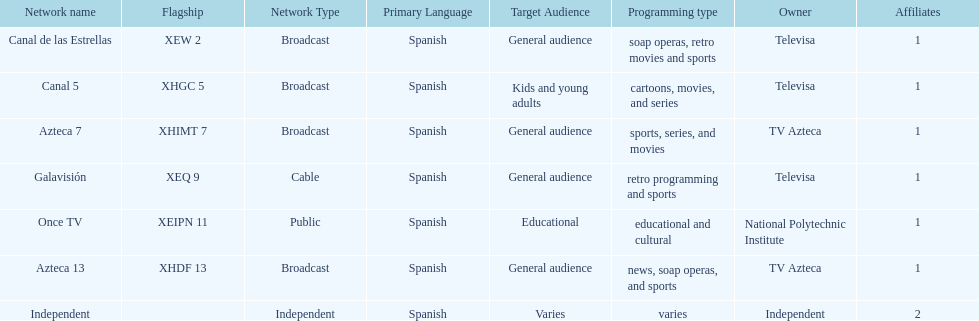What is the total number of affiliates among all the networks? 8. Write the full table. {'header': ['Network name', 'Flagship', 'Network Type', 'Primary Language', 'Target Audience', 'Programming type', 'Owner', 'Affiliates'], 'rows': [['Canal de las Estrellas', 'XEW 2', 'Broadcast', 'Spanish', 'General audience', 'soap operas, retro movies and sports', 'Televisa', '1'], ['Canal 5', 'XHGC 5', 'Broadcast', 'Spanish', 'Kids and young adults', 'cartoons, movies, and series', 'Televisa', '1'], ['Azteca 7', 'XHIMT 7', 'Broadcast', 'Spanish', 'General audience', 'sports, series, and movies', 'TV Azteca', '1'], ['Galavisión', 'XEQ 9', 'Cable', 'Spanish', 'General audience', 'retro programming and sports', 'Televisa', '1'], ['Once TV', 'XEIPN 11', 'Public', 'Spanish', 'Educational', 'educational and cultural', 'National Polytechnic Institute', '1'], ['Azteca 13', 'XHDF 13', 'Broadcast', 'Spanish', 'General audience', 'news, soap operas, and sports', 'TV Azteca', '1'], ['Independent', '', 'Independent', 'Spanish', 'Varies', 'varies', 'Independent', '2']]} 